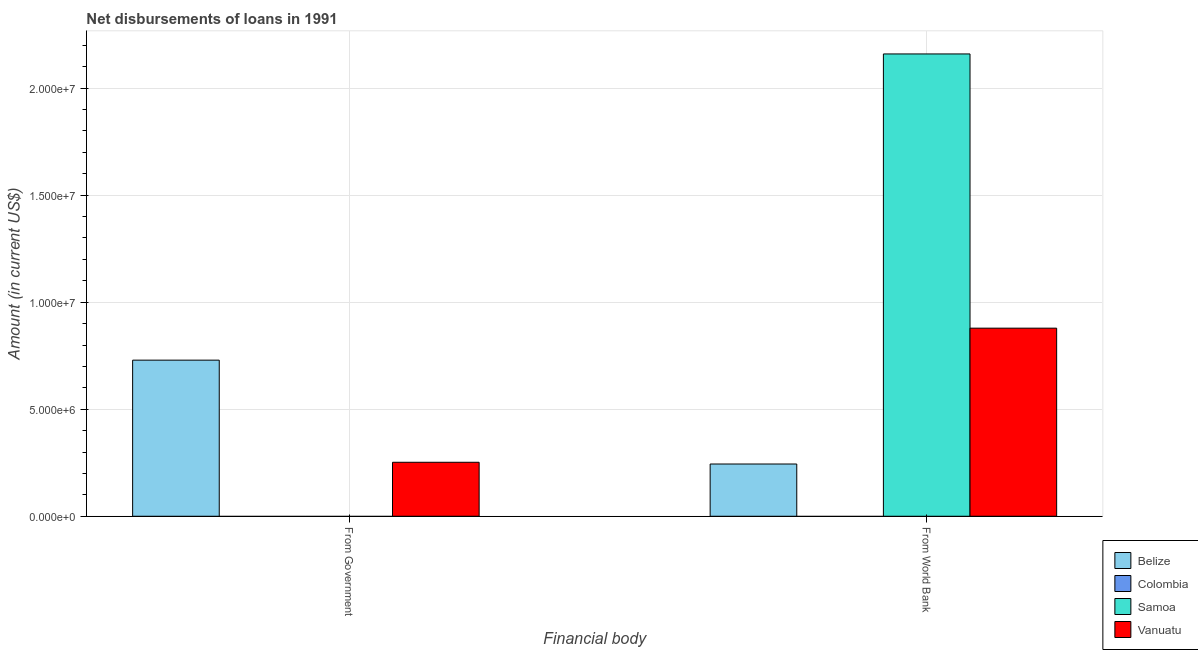How many different coloured bars are there?
Provide a succinct answer. 3. Are the number of bars per tick equal to the number of legend labels?
Your response must be concise. No. Are the number of bars on each tick of the X-axis equal?
Your answer should be compact. No. How many bars are there on the 1st tick from the left?
Ensure brevity in your answer.  2. How many bars are there on the 1st tick from the right?
Give a very brief answer. 3. What is the label of the 2nd group of bars from the left?
Provide a short and direct response. From World Bank. What is the net disbursements of loan from world bank in Vanuatu?
Your answer should be compact. 8.79e+06. Across all countries, what is the maximum net disbursements of loan from government?
Keep it short and to the point. 7.29e+06. In which country was the net disbursements of loan from government maximum?
Offer a terse response. Belize. What is the total net disbursements of loan from government in the graph?
Keep it short and to the point. 9.82e+06. What is the difference between the net disbursements of loan from world bank in Belize and that in Samoa?
Offer a very short reply. -1.92e+07. What is the difference between the net disbursements of loan from government in Belize and the net disbursements of loan from world bank in Colombia?
Offer a terse response. 7.29e+06. What is the average net disbursements of loan from world bank per country?
Your response must be concise. 8.21e+06. What is the difference between the net disbursements of loan from world bank and net disbursements of loan from government in Belize?
Your response must be concise. -4.85e+06. In how many countries, is the net disbursements of loan from government greater than 5000000 US$?
Offer a very short reply. 1. What is the ratio of the net disbursements of loan from government in Vanuatu to that in Belize?
Your answer should be compact. 0.35. In how many countries, is the net disbursements of loan from world bank greater than the average net disbursements of loan from world bank taken over all countries?
Give a very brief answer. 2. What is the difference between two consecutive major ticks on the Y-axis?
Your answer should be very brief. 5.00e+06. Does the graph contain grids?
Provide a succinct answer. Yes. Where does the legend appear in the graph?
Keep it short and to the point. Bottom right. How many legend labels are there?
Provide a short and direct response. 4. What is the title of the graph?
Give a very brief answer. Net disbursements of loans in 1991. Does "Caribbean small states" appear as one of the legend labels in the graph?
Offer a very short reply. No. What is the label or title of the X-axis?
Provide a succinct answer. Financial body. What is the Amount (in current US$) in Belize in From Government?
Your answer should be compact. 7.29e+06. What is the Amount (in current US$) of Vanuatu in From Government?
Provide a short and direct response. 2.52e+06. What is the Amount (in current US$) in Belize in From World Bank?
Ensure brevity in your answer.  2.44e+06. What is the Amount (in current US$) of Colombia in From World Bank?
Provide a succinct answer. 0. What is the Amount (in current US$) in Samoa in From World Bank?
Ensure brevity in your answer.  2.16e+07. What is the Amount (in current US$) of Vanuatu in From World Bank?
Offer a terse response. 8.79e+06. Across all Financial body, what is the maximum Amount (in current US$) in Belize?
Your answer should be compact. 7.29e+06. Across all Financial body, what is the maximum Amount (in current US$) in Samoa?
Keep it short and to the point. 2.16e+07. Across all Financial body, what is the maximum Amount (in current US$) in Vanuatu?
Your answer should be very brief. 8.79e+06. Across all Financial body, what is the minimum Amount (in current US$) of Belize?
Keep it short and to the point. 2.44e+06. Across all Financial body, what is the minimum Amount (in current US$) of Samoa?
Offer a terse response. 0. Across all Financial body, what is the minimum Amount (in current US$) in Vanuatu?
Your answer should be very brief. 2.52e+06. What is the total Amount (in current US$) of Belize in the graph?
Offer a terse response. 9.73e+06. What is the total Amount (in current US$) in Colombia in the graph?
Your answer should be very brief. 0. What is the total Amount (in current US$) in Samoa in the graph?
Your response must be concise. 2.16e+07. What is the total Amount (in current US$) of Vanuatu in the graph?
Your answer should be very brief. 1.13e+07. What is the difference between the Amount (in current US$) in Belize in From Government and that in From World Bank?
Offer a terse response. 4.85e+06. What is the difference between the Amount (in current US$) in Vanuatu in From Government and that in From World Bank?
Give a very brief answer. -6.26e+06. What is the difference between the Amount (in current US$) in Belize in From Government and the Amount (in current US$) in Samoa in From World Bank?
Your response must be concise. -1.43e+07. What is the difference between the Amount (in current US$) of Belize in From Government and the Amount (in current US$) of Vanuatu in From World Bank?
Offer a very short reply. -1.49e+06. What is the average Amount (in current US$) in Belize per Financial body?
Give a very brief answer. 4.87e+06. What is the average Amount (in current US$) in Samoa per Financial body?
Make the answer very short. 1.08e+07. What is the average Amount (in current US$) in Vanuatu per Financial body?
Offer a terse response. 5.65e+06. What is the difference between the Amount (in current US$) in Belize and Amount (in current US$) in Vanuatu in From Government?
Give a very brief answer. 4.77e+06. What is the difference between the Amount (in current US$) of Belize and Amount (in current US$) of Samoa in From World Bank?
Offer a very short reply. -1.92e+07. What is the difference between the Amount (in current US$) of Belize and Amount (in current US$) of Vanuatu in From World Bank?
Your response must be concise. -6.35e+06. What is the difference between the Amount (in current US$) of Samoa and Amount (in current US$) of Vanuatu in From World Bank?
Ensure brevity in your answer.  1.28e+07. What is the ratio of the Amount (in current US$) in Belize in From Government to that in From World Bank?
Offer a very short reply. 2.99. What is the ratio of the Amount (in current US$) in Vanuatu in From Government to that in From World Bank?
Your answer should be very brief. 0.29. What is the difference between the highest and the second highest Amount (in current US$) in Belize?
Your answer should be very brief. 4.85e+06. What is the difference between the highest and the second highest Amount (in current US$) of Vanuatu?
Provide a short and direct response. 6.26e+06. What is the difference between the highest and the lowest Amount (in current US$) of Belize?
Your response must be concise. 4.85e+06. What is the difference between the highest and the lowest Amount (in current US$) of Samoa?
Your answer should be compact. 2.16e+07. What is the difference between the highest and the lowest Amount (in current US$) in Vanuatu?
Your answer should be compact. 6.26e+06. 